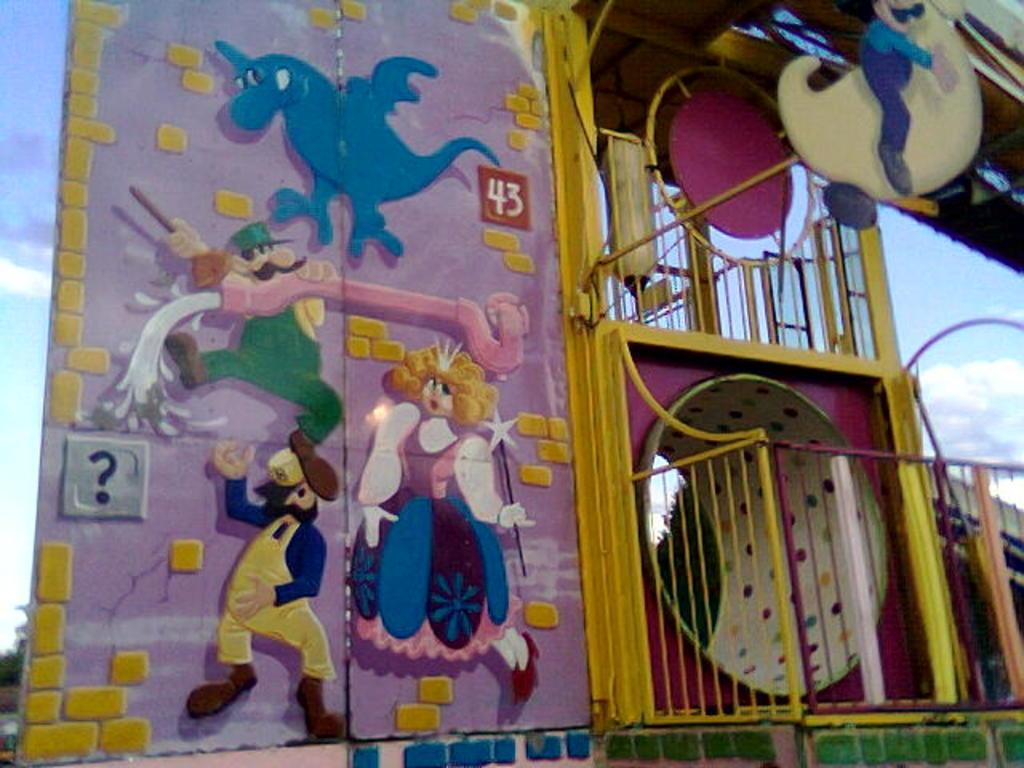What is the main subject in the center of the image? There is a fun ride game in the center of the image. What can be seen in the background of the image? The sky is visible in the background of the image. Are there any specific weather conditions visible in the background? Yes, clouds are present in the background of the image. What type of rice can be seen in the image? There is no rice present in the image. Is there a judge overseeing the fun ride game in the image? There is no judge present in the image; it only features the fun ride game and the sky in the background. 